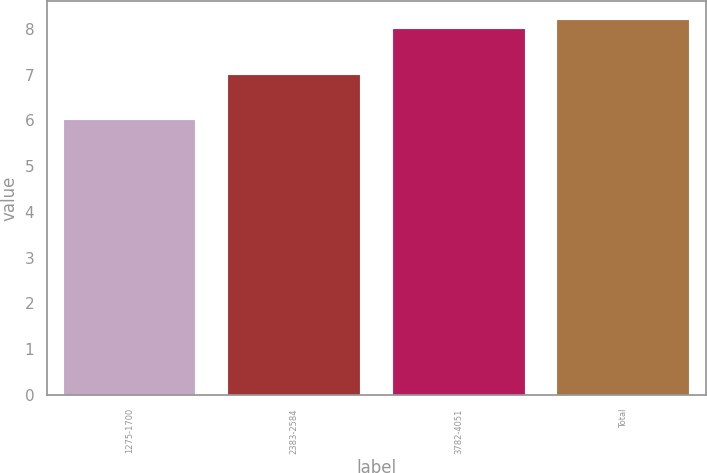Convert chart to OTSL. <chart><loc_0><loc_0><loc_500><loc_500><bar_chart><fcel>1275-1700<fcel>2383-2584<fcel>3782-4051<fcel>Total<nl><fcel>6<fcel>7<fcel>8<fcel>8.2<nl></chart> 